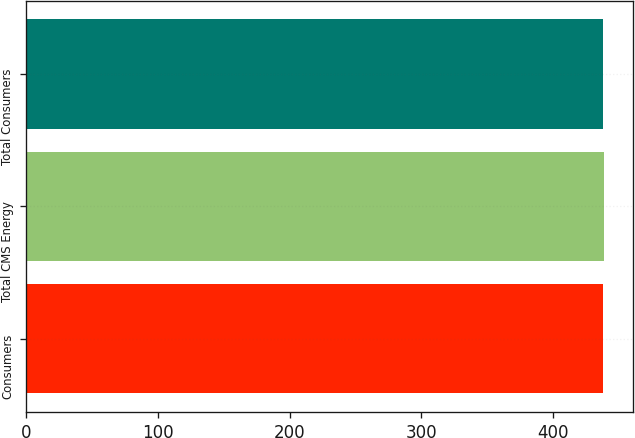Convert chart to OTSL. <chart><loc_0><loc_0><loc_500><loc_500><bar_chart><fcel>Consumers<fcel>Total CMS Energy<fcel>Total Consumers<nl><fcel>438<fcel>439<fcel>438.1<nl></chart> 